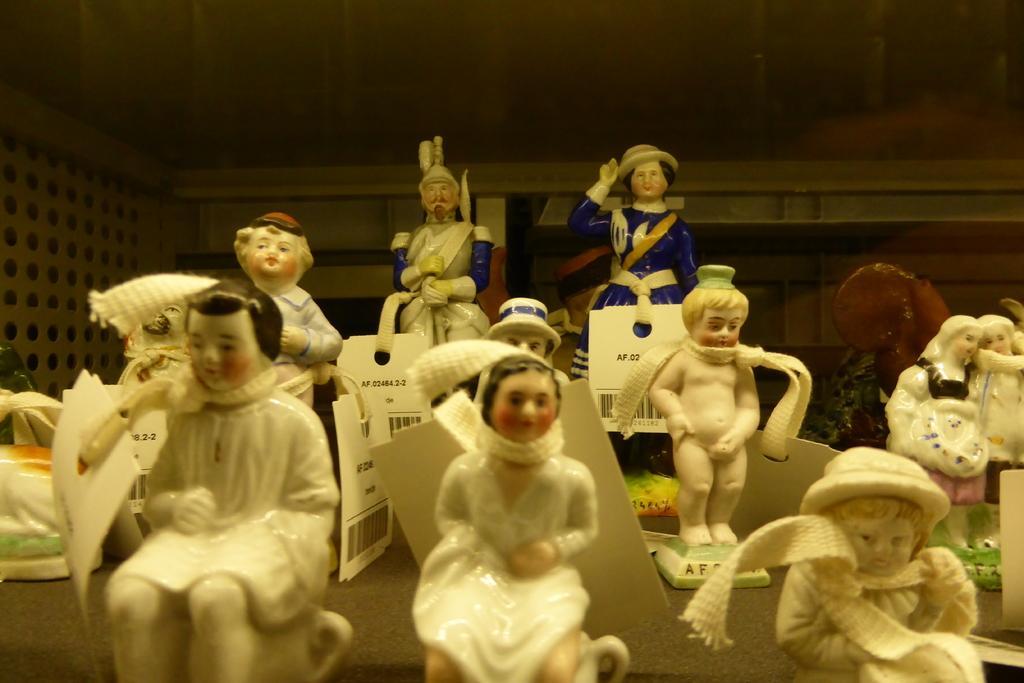Describe this image in one or two sentences. In this picture I can see some toys with tags. 